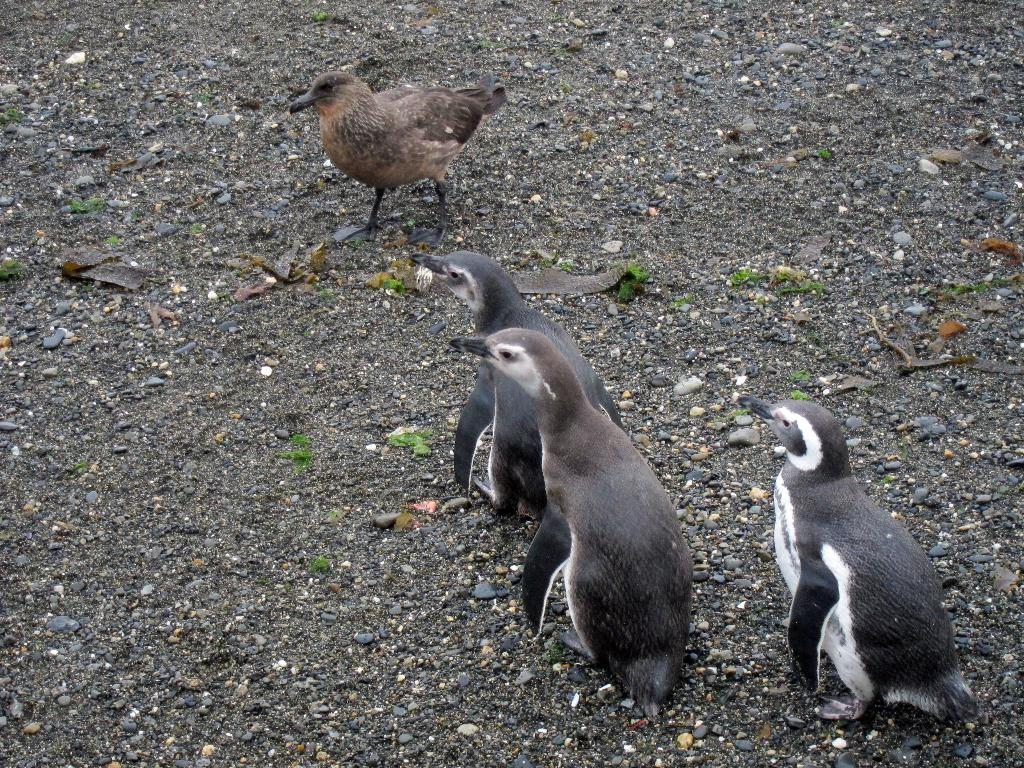What type of animals are present in the image? There are penguins in the image. Can you identify any other type of animal in the image? Yes, there is a bird in the image. What type of leather is used to make the carriage in the image? There is no carriage present in the image; it only features penguins and a bird. 